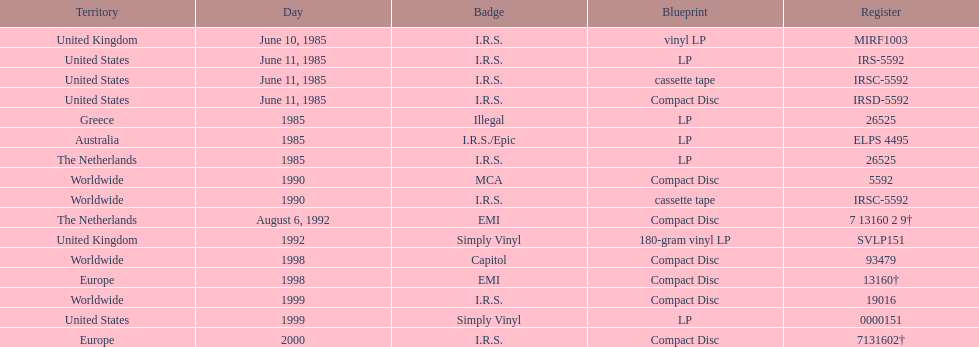Which area was the final to launch? Europe. 